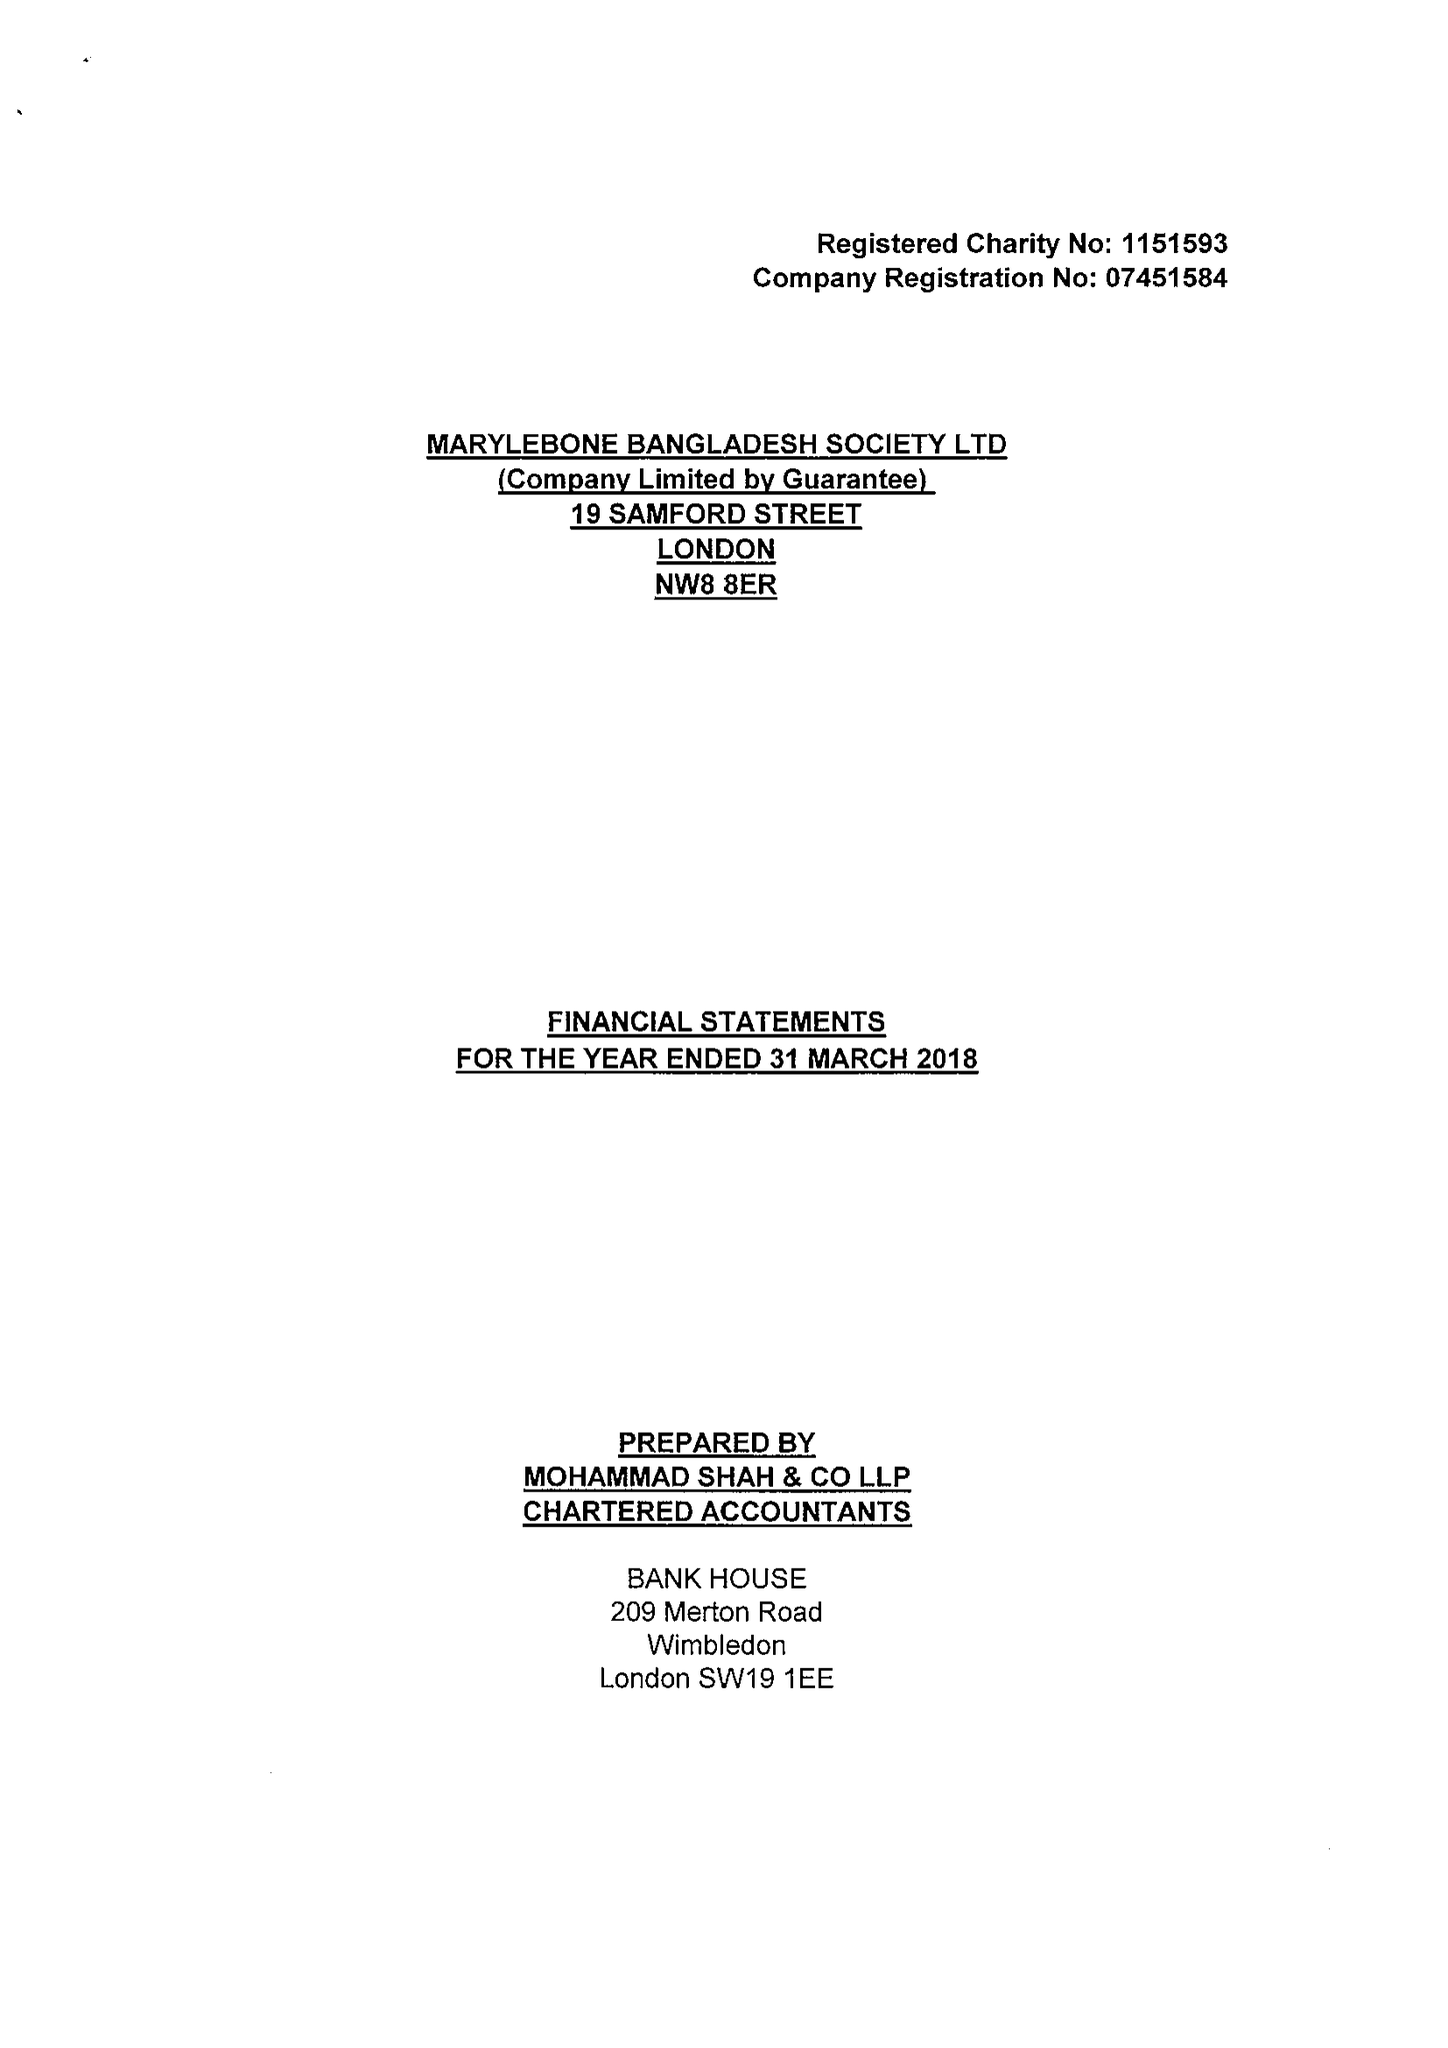What is the value for the charity_name?
Answer the question using a single word or phrase. Marylebone Bangladesh Society Ltd. 